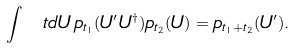<formula> <loc_0><loc_0><loc_500><loc_500>\int \ t { d } U \, p _ { t _ { 1 } } ( U ^ { \prime } U ^ { \dagger } ) p _ { t _ { 2 } } ( U ) = p _ { t _ { 1 } + t _ { 2 } } ( U ^ { \prime } ) .</formula> 